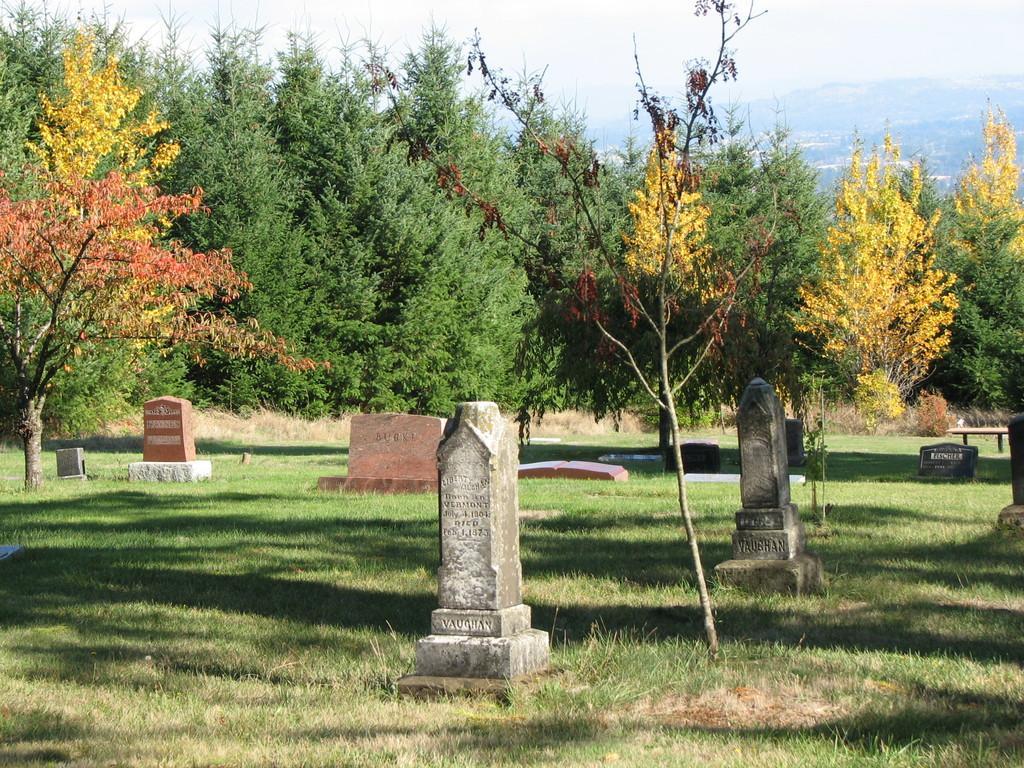In one or two sentences, can you explain what this image depicts? In this picture we can see graves on the ground, here we can see a bench, grass, trees and in the background we can see a mountain, sky. 